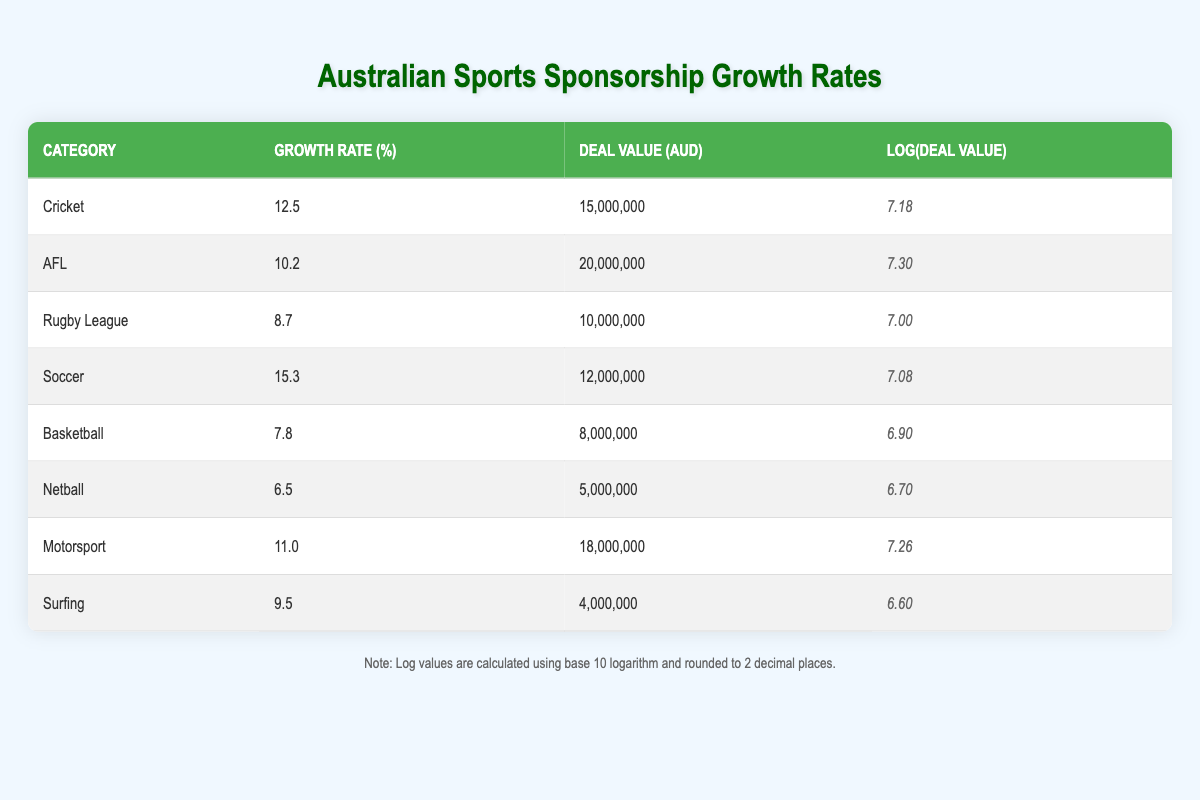What is the growth rate for Cricket sponsorship deals? The table shows the data for Cricket in the first row, indicating a growth rate of 12.5%.
Answer: 12.5% Which sport has the highest deal value? By comparing all deal values in the table, AFL has the highest value at 20,000,000 AUD.
Answer: 20,000,000 AUD What is the median growth rate of the sports listed? First, the growth rates in order are: 6.5, 7.8, 8.7, 9.5, 10.2, 11.0, 12.5, 15.3. There are 8 values, so the median is the average of the 4th and 5th, (9.5 + 10.2) / 2 = 9.85.
Answer: 9.85 Is the growth rate for Basketball higher than that of Rugby League? The growth rate for Basketball is 7.8% while Rugby League is 8.7%. Since 7.8 is less than 8.7, the statement is false.
Answer: No What is the average deal value for sports with a growth rate above 10%? The sports with a growth rate above 10% are Cricket (15,000,000), AFL (20,000,000), Soccer (12,000,000), and Motorsport (18,000,000). The sum of these deal values is 15,000,000 + 20,000,000 + 12,000,000 + 18,000,000 = 65,000,000. With 4 sports, the average is 65,000,000 / 4 = 16,250,000.
Answer: 16,250,000 Which sport has a growth rate closest to the average growth rate of the table? The growth rates are: 12.5, 10.2, 8.7, 15.3, 7.8, 6.5, 11.0, and 9.5. The average growth rate is (12.5 + 10.2 + 8.7 + 15.3 + 7.8 + 6.5 + 11.0 + 9.5) / 8 = 10.31. The growth rates close to this are AFL (10.2) and Motorsport (11.0).
Answer: AFL and Motorsport Is it true that all sports have a growth rate below 15%? Upon examining the growth rates, the highest is 15.3% for Soccer, which exceeds 15%. Therefore, the statement is false.
Answer: No What is the total deal value of all sports combined? To find the total, sum all deal values: 15,000,000 (Cricket) + 20,000,000 (AFL) + 10,000,000 (Rugby League) + 12,000,000 (Soccer) + 8,000,000 (Basketball) + 5,000,000 (Netball) + 18,000,000 (Motorsport) + 4,000,000 (Surfing) = 88,000,000.
Answer: 88,000,000 